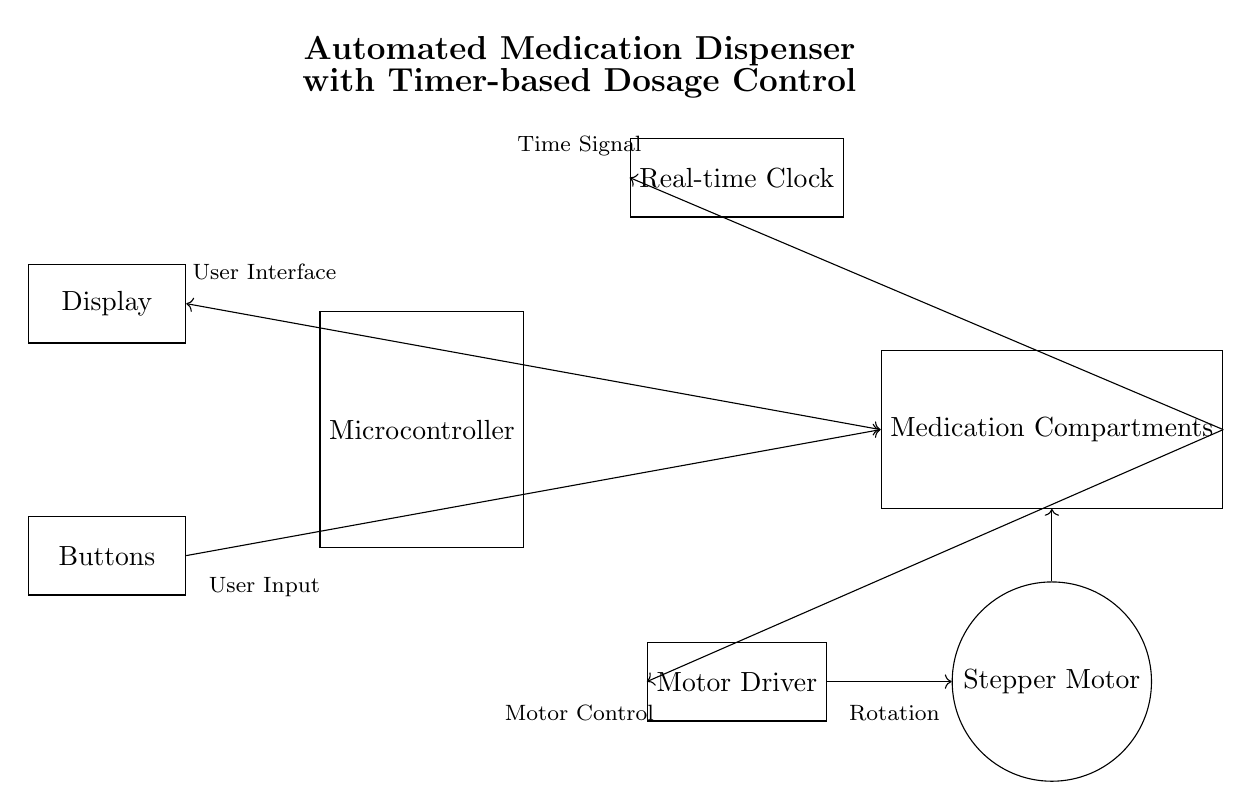What is the main component that controls the medication dispenser? The main component controlling the medication dispenser is the microcontroller, as it governs the operations and connects to other components in the circuit.
Answer: microcontroller What is the function of the real-time clock in this circuit? The real-time clock provides time signals that the microcontroller uses to schedule when medication should be dispensed, indicating the timing of operations.
Answer: time signals How does the motor driver interact with the stepper motor? The motor driver controls the stepper motor's rotational direction and speed based on signals received from the microcontroller, allowing for precise movement in dispensing medication.
Answer: controls rotation What is the user interface component in the circuit? The user interface component is the display, which presents information to the user, such as timing, medication status, and alerts for upcoming doses.
Answer: display How are the buttons connected in the circuit? The buttons connect to the microcontroller, allowing users to input commands or adjust settings for medication dispensing and timing directly.
Answer: to microcontroller What is the purpose of the medication compartments? The medication compartments are designated storage areas for different medications, and they allow for organized dispensing based on the scheduled times set by the microcontroller.
Answer: storage areas How does the circuit ensure correct dosage timing? The microcontroller uses inputs from the real-time clock to determine when to activate the motor driver, which in turn controls the stepper motor to dispense the correct dosage at specified times.
Answer: through scheduling 